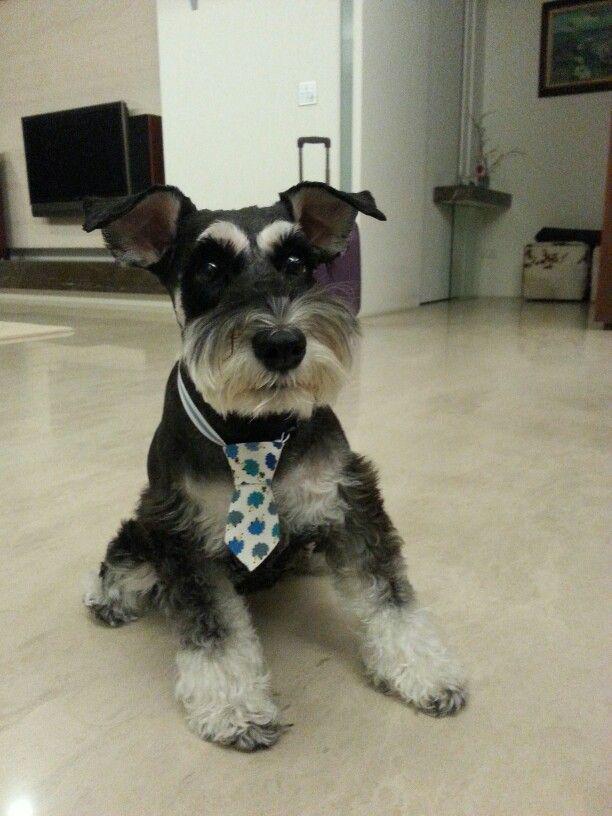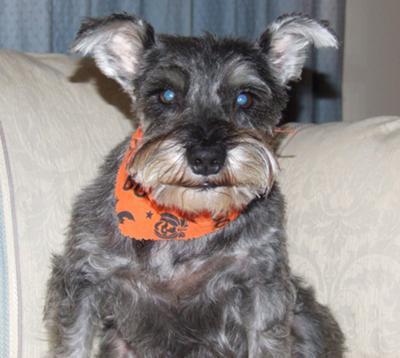The first image is the image on the left, the second image is the image on the right. Examine the images to the left and right. Is the description "There are exactly two dogs." accurate? Answer yes or no. Yes. The first image is the image on the left, the second image is the image on the right. Considering the images on both sides, is "Each image shows one forward-facing, non-standing schnauzer with a grayish coat and lighter hair on its muzzle." valid? Answer yes or no. Yes. 